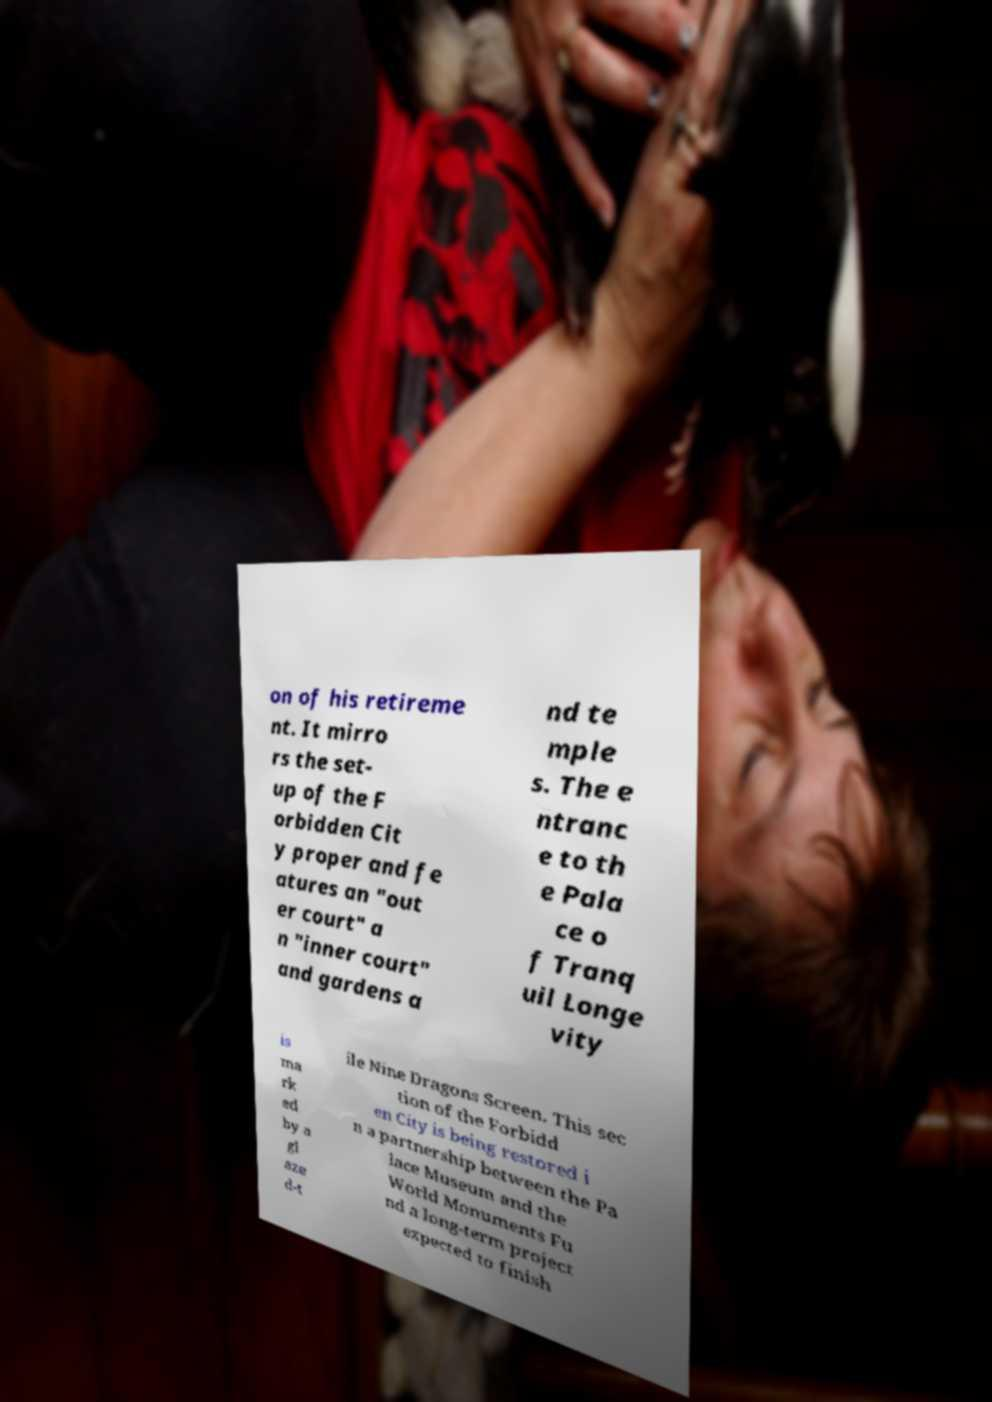Can you read and provide the text displayed in the image?This photo seems to have some interesting text. Can you extract and type it out for me? on of his retireme nt. It mirro rs the set- up of the F orbidden Cit y proper and fe atures an "out er court" a n "inner court" and gardens a nd te mple s. The e ntranc e to th e Pala ce o f Tranq uil Longe vity is ma rk ed by a gl aze d-t ile Nine Dragons Screen. This sec tion of the Forbidd en City is being restored i n a partnership between the Pa lace Museum and the World Monuments Fu nd a long-term project expected to finish 